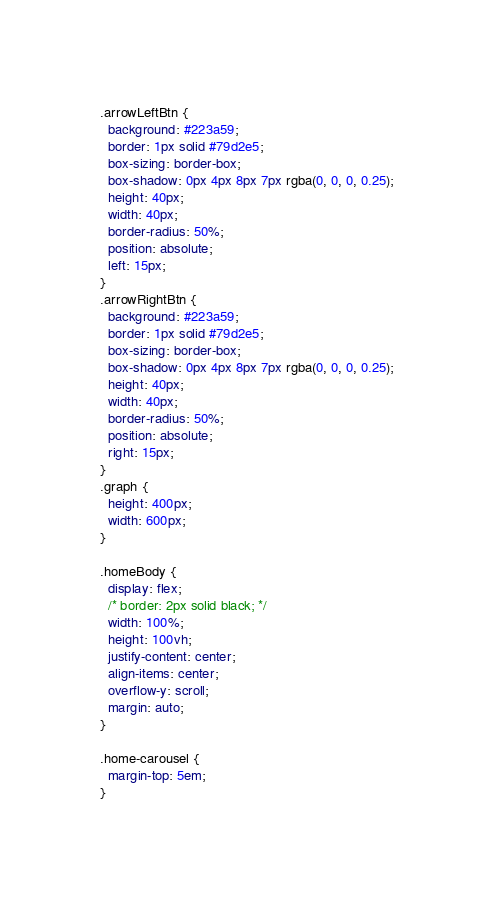<code> <loc_0><loc_0><loc_500><loc_500><_CSS_>.arrowLeftBtn {
  background: #223a59;
  border: 1px solid #79d2e5;
  box-sizing: border-box;
  box-shadow: 0px 4px 8px 7px rgba(0, 0, 0, 0.25);
  height: 40px;
  width: 40px;
  border-radius: 50%;
  position: absolute;
  left: 15px;
}
.arrowRightBtn {
  background: #223a59;
  border: 1px solid #79d2e5;
  box-sizing: border-box;
  box-shadow: 0px 4px 8px 7px rgba(0, 0, 0, 0.25);
  height: 40px;
  width: 40px;
  border-radius: 50%;
  position: absolute;
  right: 15px;
}
.graph {
  height: 400px;
  width: 600px;
}

.homeBody {
  display: flex;
  /* border: 2px solid black; */
  width: 100%;
  height: 100vh;
  justify-content: center;
  align-items: center;
  overflow-y: scroll;
  margin: auto;
}

.home-carousel {
  margin-top: 5em;
}
</code> 